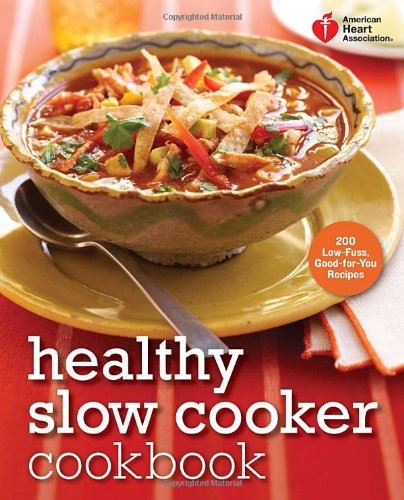Is this book related to Cookbooks, Food & Wine? Absolutely, the book is an essential resource for anyone looking to combine the convenience of slow cooking with the requirements of a health-conscious diet, rightfully placing it in the 'Cookbooks, Food & Wine' genre. 